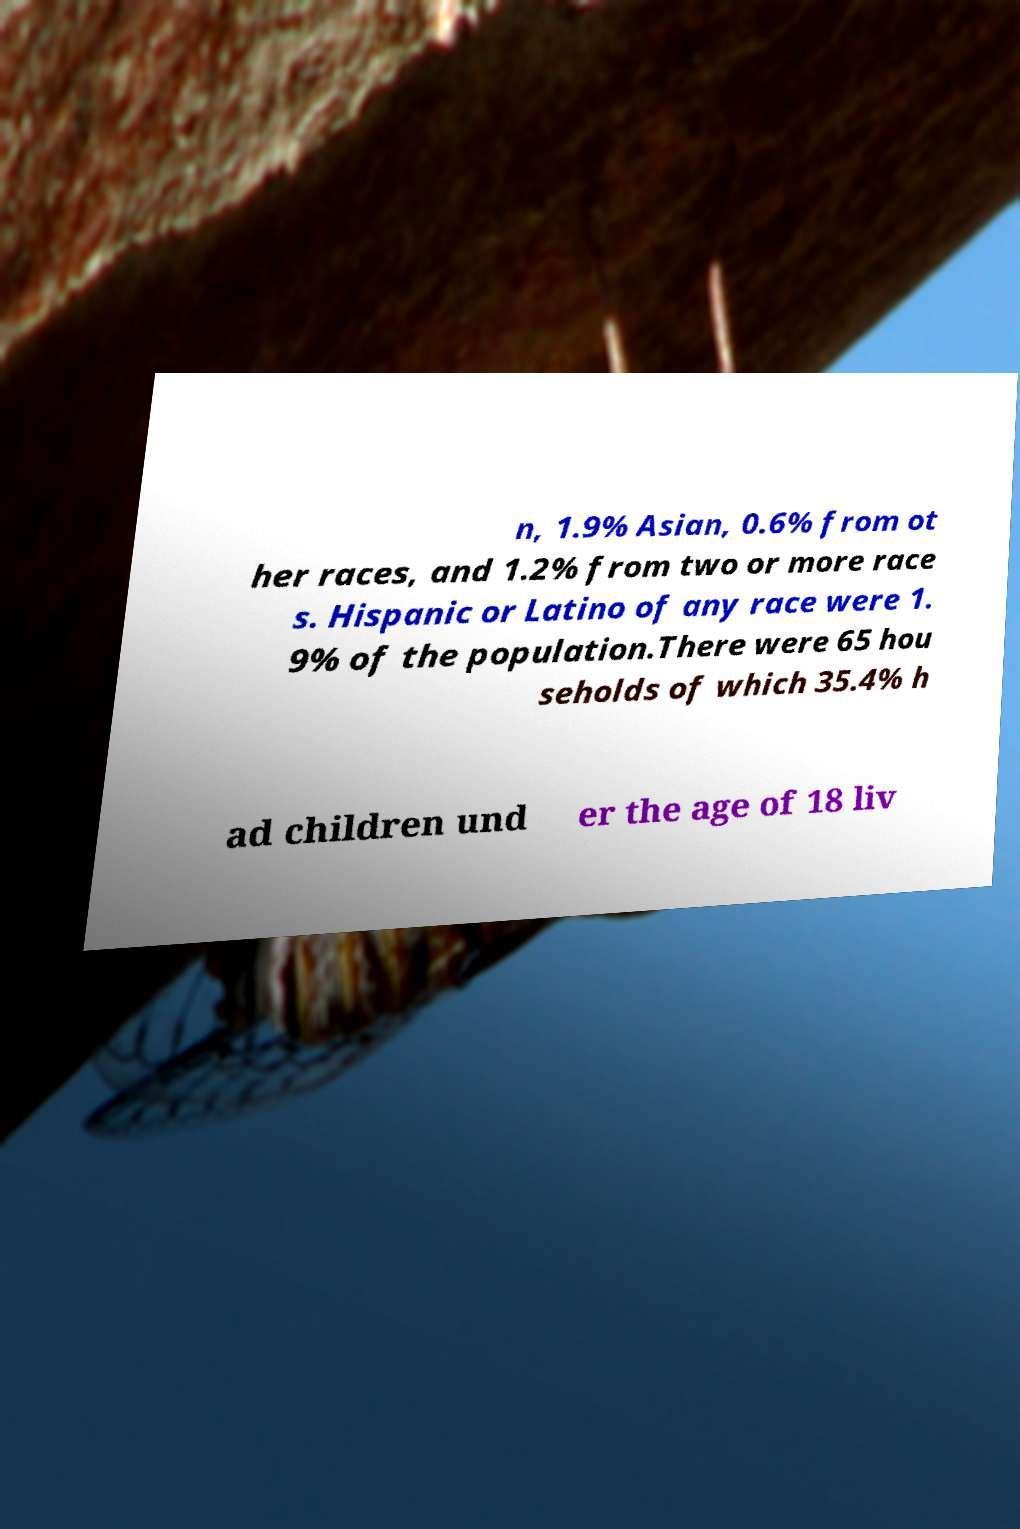For documentation purposes, I need the text within this image transcribed. Could you provide that? n, 1.9% Asian, 0.6% from ot her races, and 1.2% from two or more race s. Hispanic or Latino of any race were 1. 9% of the population.There were 65 hou seholds of which 35.4% h ad children und er the age of 18 liv 